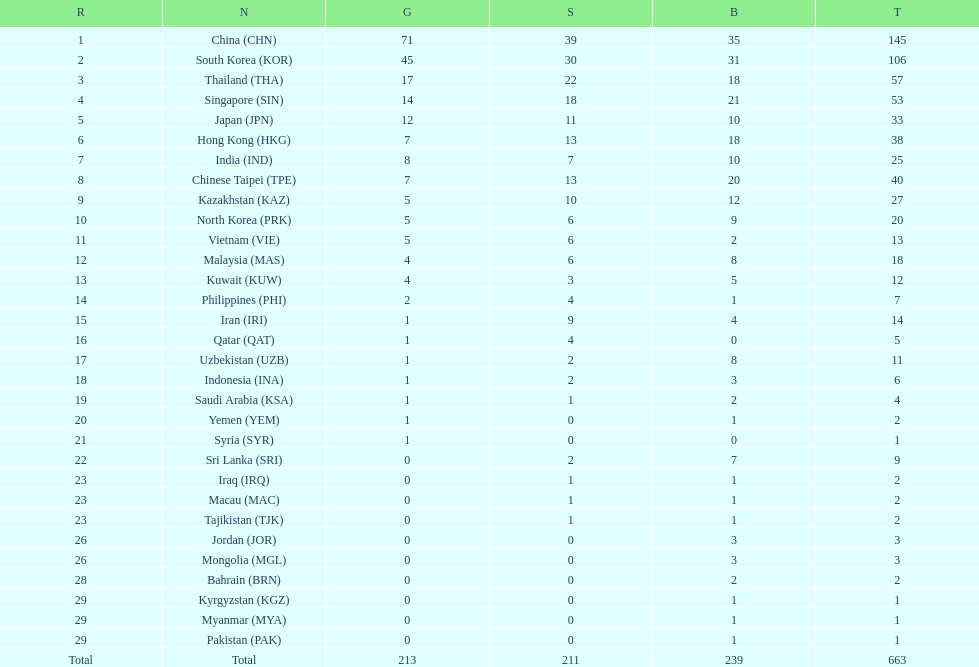Which countries have the same number of silver medals in the asian youth games as north korea? Vietnam (VIE), Malaysia (MAS). 